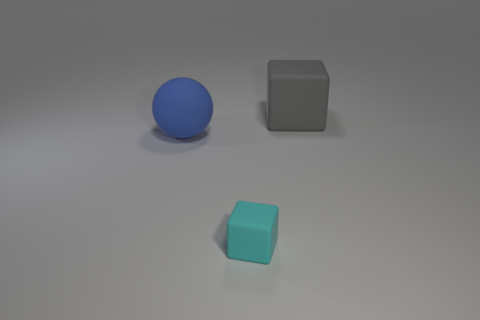Is the number of yellow matte spheres less than the number of matte cubes?
Provide a succinct answer. Yes. There is a blue rubber ball; is its size the same as the cube behind the matte ball?
Your answer should be very brief. Yes. What number of rubber objects are tiny cyan cubes or big things?
Offer a terse response. 3. Is the number of cyan cylinders greater than the number of large matte blocks?
Ensure brevity in your answer.  No. The big object that is on the right side of the matte cube that is in front of the gray matte cube is what shape?
Your answer should be very brief. Cube. Are there any small cyan rubber cubes on the right side of the rubber block that is left of the large gray object behind the large blue matte ball?
Give a very brief answer. No. What color is the cube that is the same size as the blue rubber sphere?
Provide a succinct answer. Gray. What shape is the rubber thing that is both in front of the big gray object and behind the small cyan cube?
Ensure brevity in your answer.  Sphere. What size is the matte cube in front of the thing behind the large blue rubber ball?
Your response must be concise. Small. How many rubber objects have the same color as the sphere?
Ensure brevity in your answer.  0. 